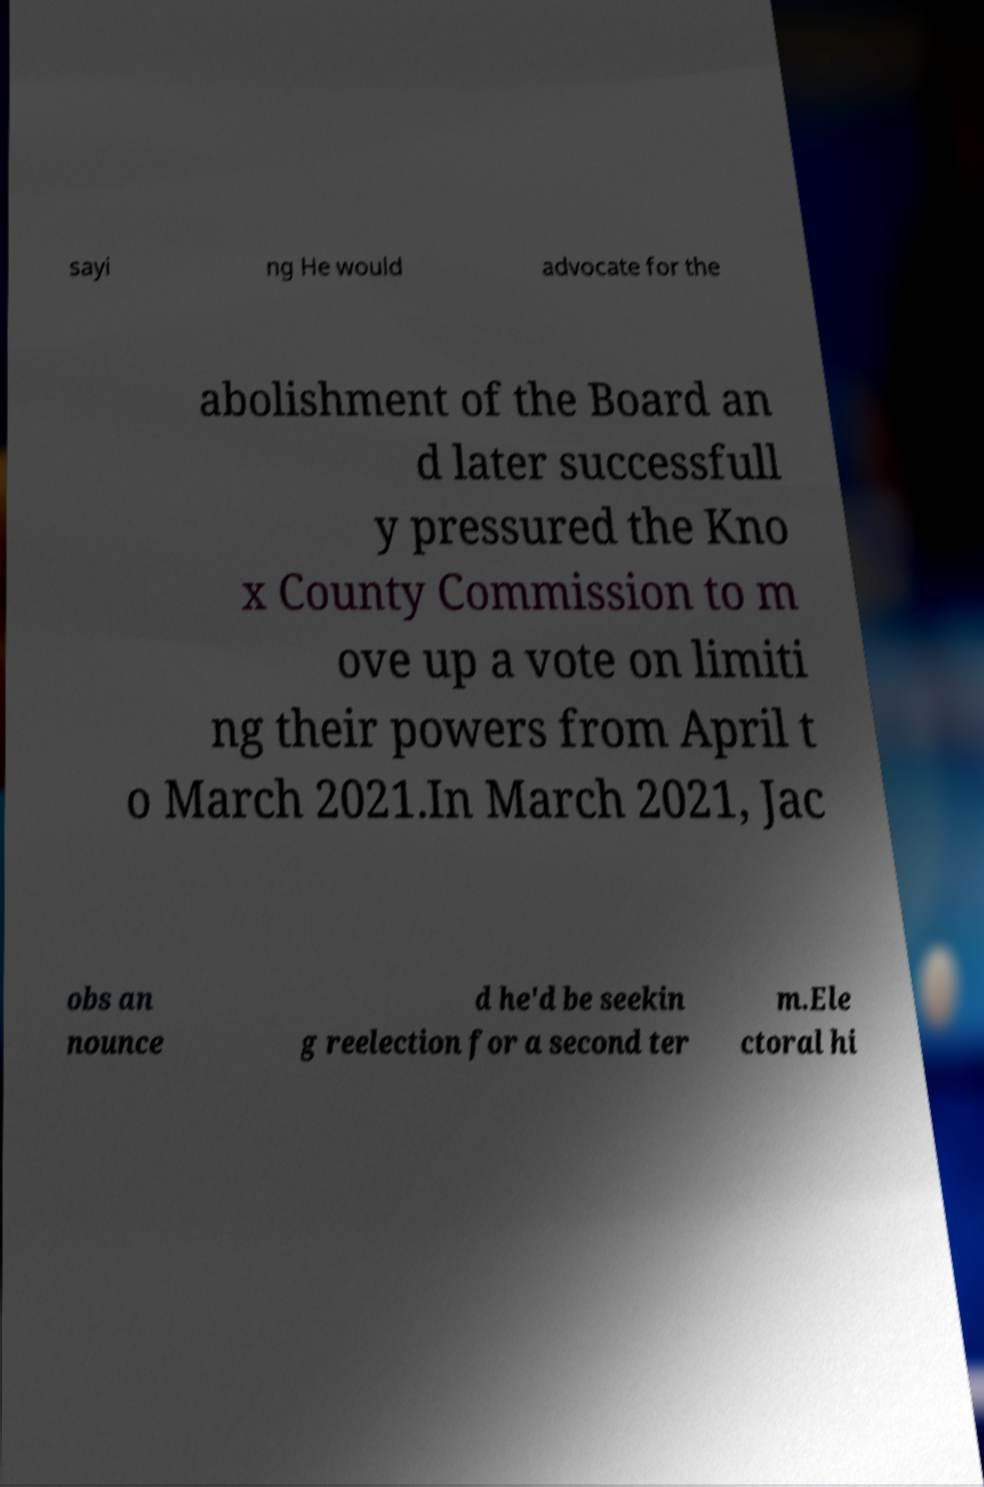There's text embedded in this image that I need extracted. Can you transcribe it verbatim? sayi ng He would advocate for the abolishment of the Board an d later successfull y pressured the Kno x County Commission to m ove up a vote on limiti ng their powers from April t o March 2021.In March 2021, Jac obs an nounce d he'd be seekin g reelection for a second ter m.Ele ctoral hi 